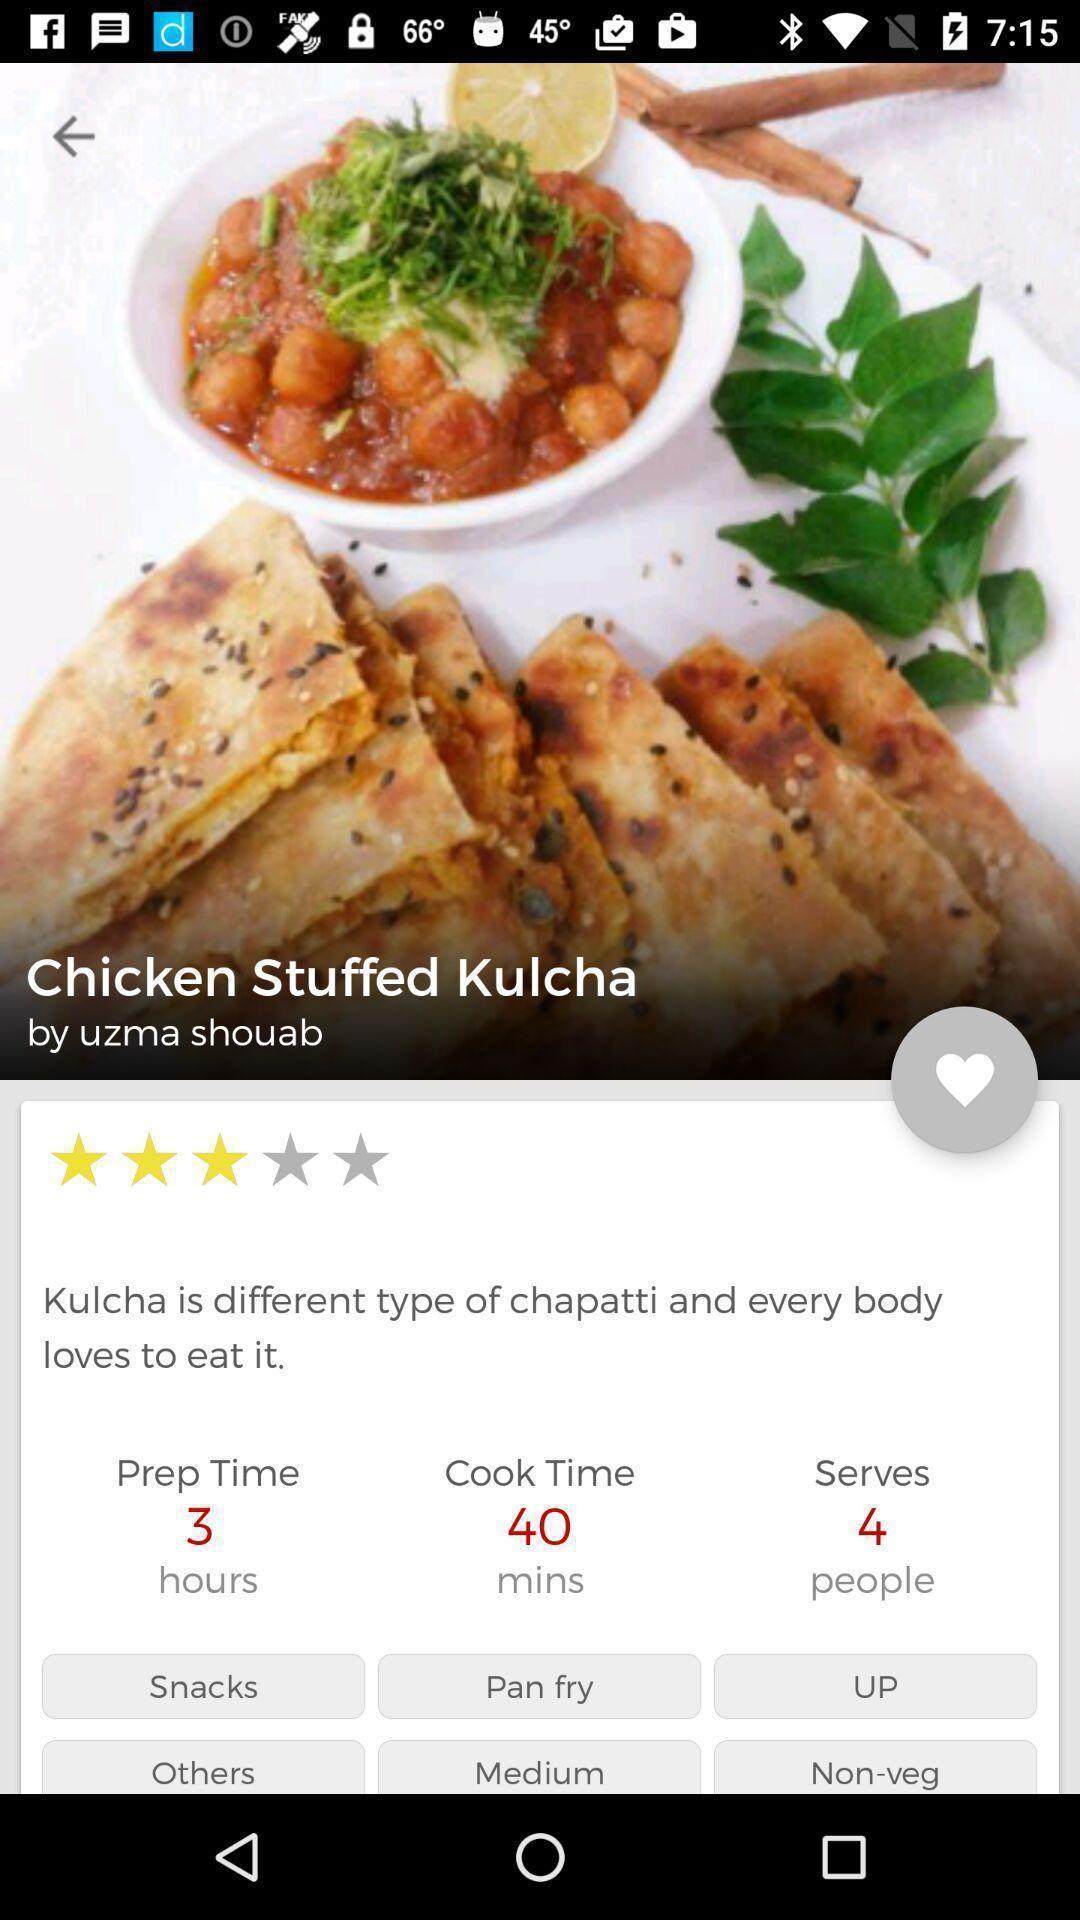What details can you identify in this image? Page showing different recipes and videos available. 